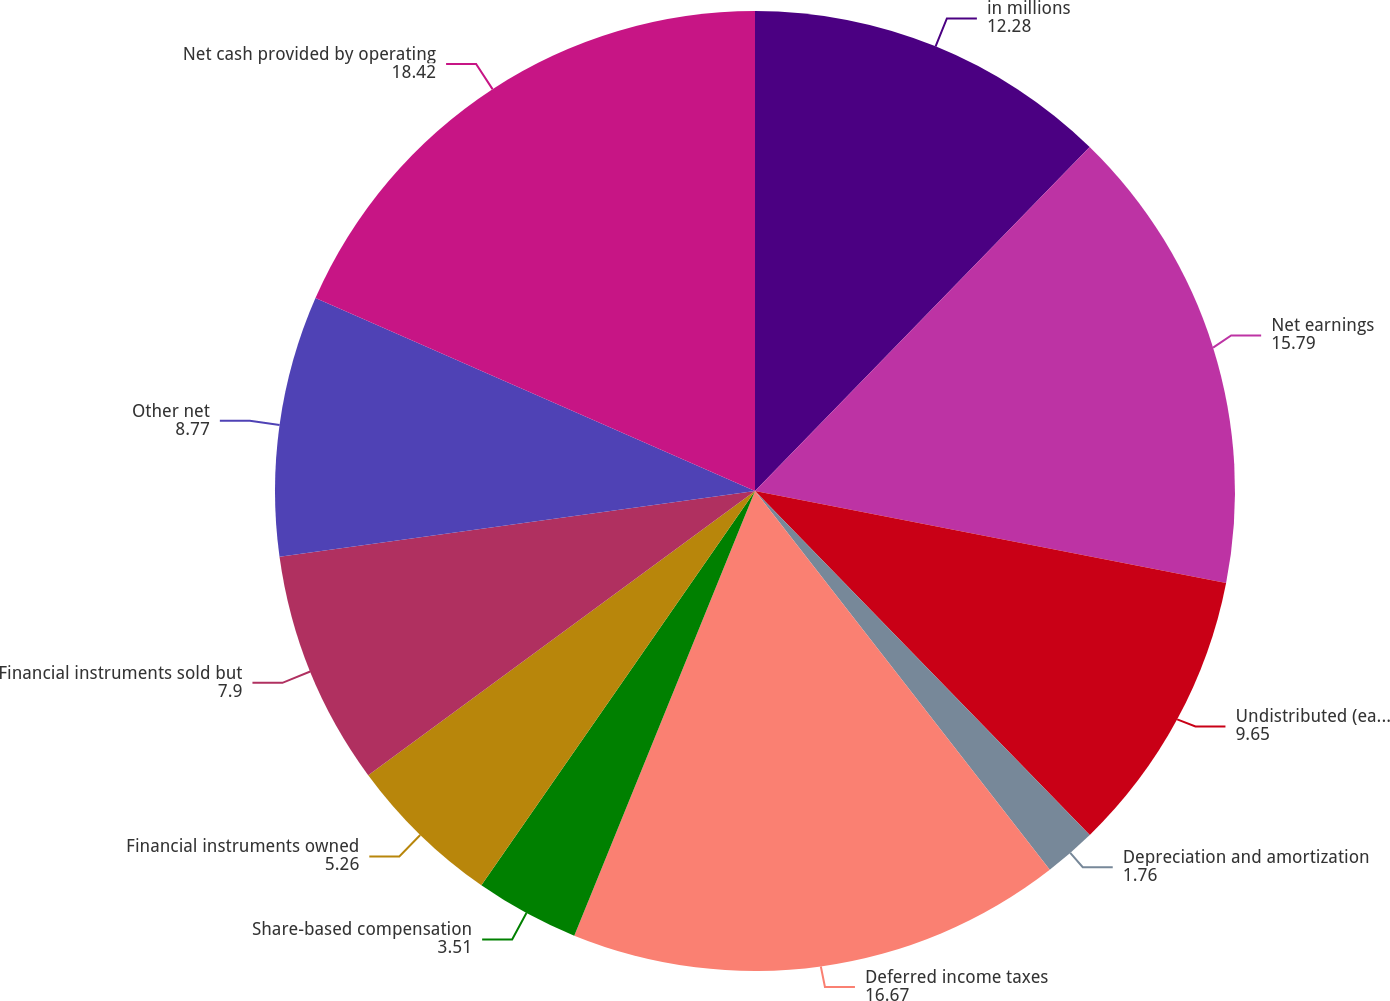Convert chart to OTSL. <chart><loc_0><loc_0><loc_500><loc_500><pie_chart><fcel>in millions<fcel>Net earnings<fcel>Undistributed (earnings)/loss<fcel>Depreciation and amortization<fcel>Deferred income taxes<fcel>Share-based compensation<fcel>Financial instruments owned<fcel>Financial instruments sold but<fcel>Other net<fcel>Net cash provided by operating<nl><fcel>12.28%<fcel>15.79%<fcel>9.65%<fcel>1.76%<fcel>16.67%<fcel>3.51%<fcel>5.26%<fcel>7.9%<fcel>8.77%<fcel>18.42%<nl></chart> 